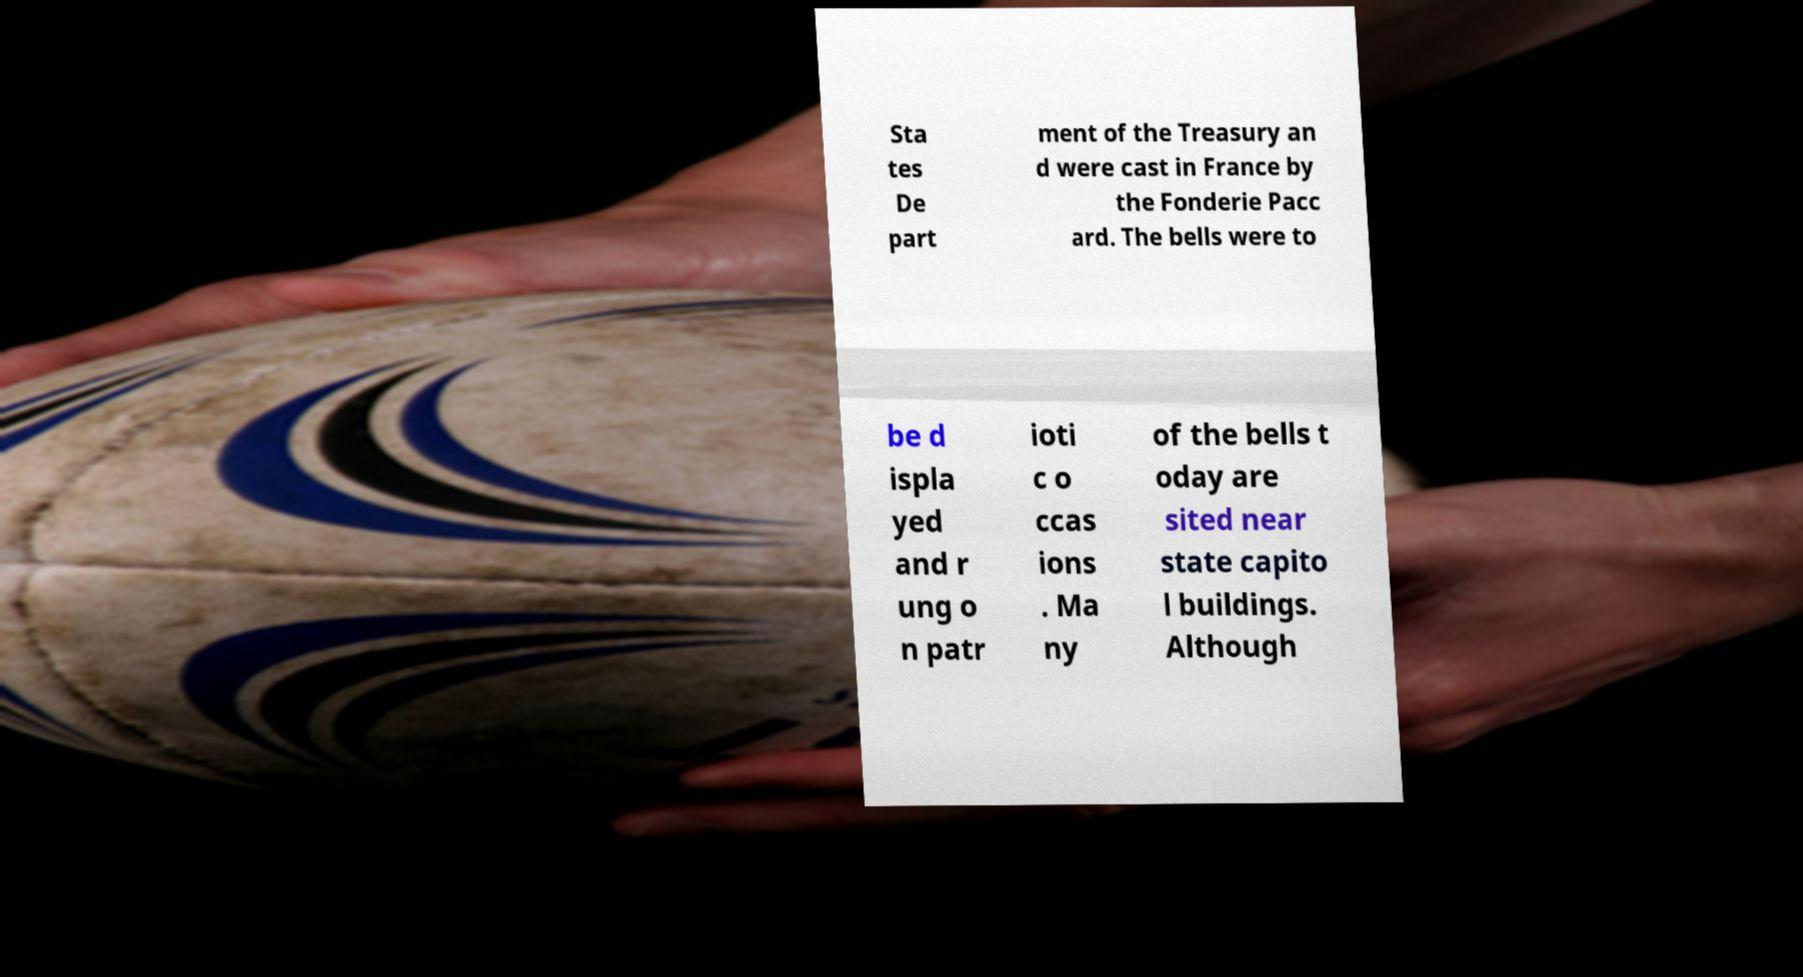For documentation purposes, I need the text within this image transcribed. Could you provide that? Sta tes De part ment of the Treasury an d were cast in France by the Fonderie Pacc ard. The bells were to be d ispla yed and r ung o n patr ioti c o ccas ions . Ma ny of the bells t oday are sited near state capito l buildings. Although 